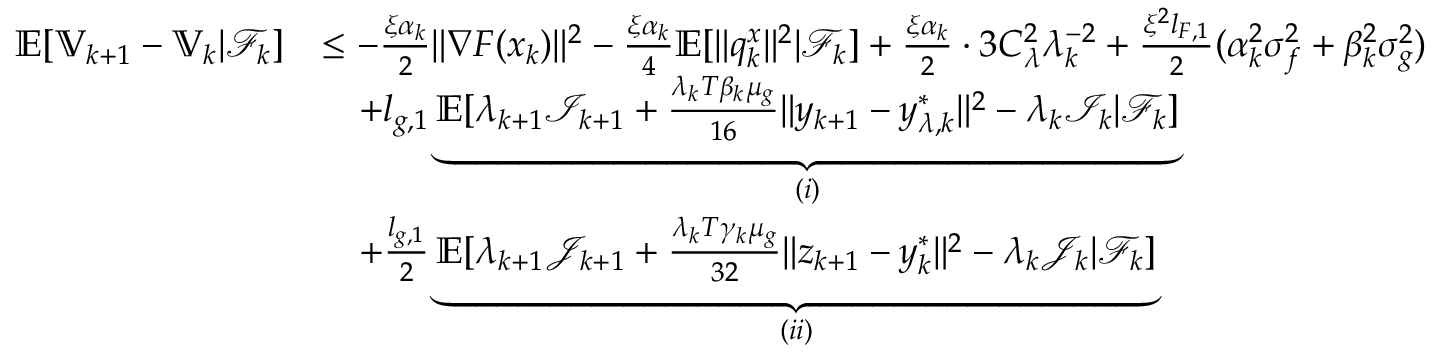Convert formula to latex. <formula><loc_0><loc_0><loc_500><loc_500>\begin{array} { r l } { \mathbb { E } [ \mathbb { V } _ { k + 1 } - \mathbb { V } _ { k } | \mathcal { F } _ { k } ] } & { \leq - \frac { \xi \alpha _ { k } } { 2 } \| \nabla F ( x _ { k } ) \| ^ { 2 } - \frac { \xi \alpha _ { k } } { 4 } \mathbb { E } [ \| q _ { k } ^ { x } \| ^ { 2 } | \mathcal { F } _ { k } ] + \frac { \xi \alpha _ { k } } { 2 } \cdot 3 C _ { \lambda } ^ { 2 } \lambda _ { k } ^ { - 2 } + \frac { \xi ^ { 2 } l _ { F , 1 } } { 2 } ( \alpha _ { k } ^ { 2 } \sigma _ { f } ^ { 2 } + \beta _ { k } ^ { 2 } \sigma _ { g } ^ { 2 } ) } \\ & { \quad + l _ { g , 1 } \underbrace { \mathbb { E } [ \lambda _ { k + 1 } \mathcal { I } _ { k + 1 } + \frac { \lambda _ { k } T \beta _ { k } \mu _ { g } } { 1 6 } \| y _ { k + 1 } - y _ { \lambda , k } ^ { * } \| ^ { 2 } - \lambda _ { k } \mathcal { I } _ { k } | \mathcal { F } _ { k } ] } _ { ( i ) } } \\ & { \quad + \frac { l _ { g , 1 } } { 2 } \underbrace { \mathbb { E } [ \lambda _ { k + 1 } \mathcal { J } _ { k + 1 } + \frac { \lambda _ { k } T \gamma _ { k } \mu _ { g } } { 3 2 } \| z _ { k + 1 } - y _ { k } ^ { * } \| ^ { 2 } - \lambda _ { k } \mathcal { J } _ { k } | \mathcal { F } _ { k } ] } _ { ( i i ) } } \end{array}</formula> 